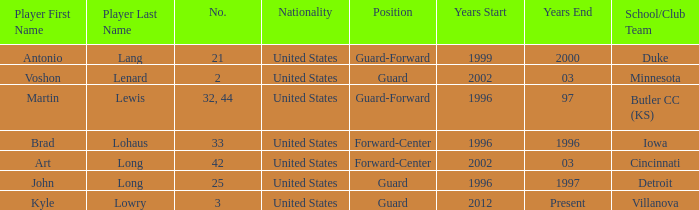Could you parse the entire table as a dict? {'header': ['Player First Name', 'Player Last Name', 'No.', 'Nationality', 'Position', 'Years Start', 'Years End', 'School/Club Team'], 'rows': [['Antonio', 'Lang', '21', 'United States', 'Guard-Forward', '1999', '2000', 'Duke'], ['Voshon', 'Lenard', '2', 'United States', 'Guard', '2002', '03', 'Minnesota'], ['Martin', 'Lewis', '32, 44', 'United States', 'Guard-Forward', '1996', '97', 'Butler CC (KS)'], ['Brad', 'Lohaus', '33', 'United States', 'Forward-Center', '1996', '1996', 'Iowa'], ['Art', 'Long', '42', 'United States', 'Forward-Center', '2002', '03', 'Cincinnati'], ['John', 'Long', '25', 'United States', 'Guard', '1996', '1997', 'Detroit'], ['Kyle', 'Lowry', '3', 'United States', 'Guard', '2012', 'Present', 'Villanova']]} Who is the participant with the number 42? Art Long. 